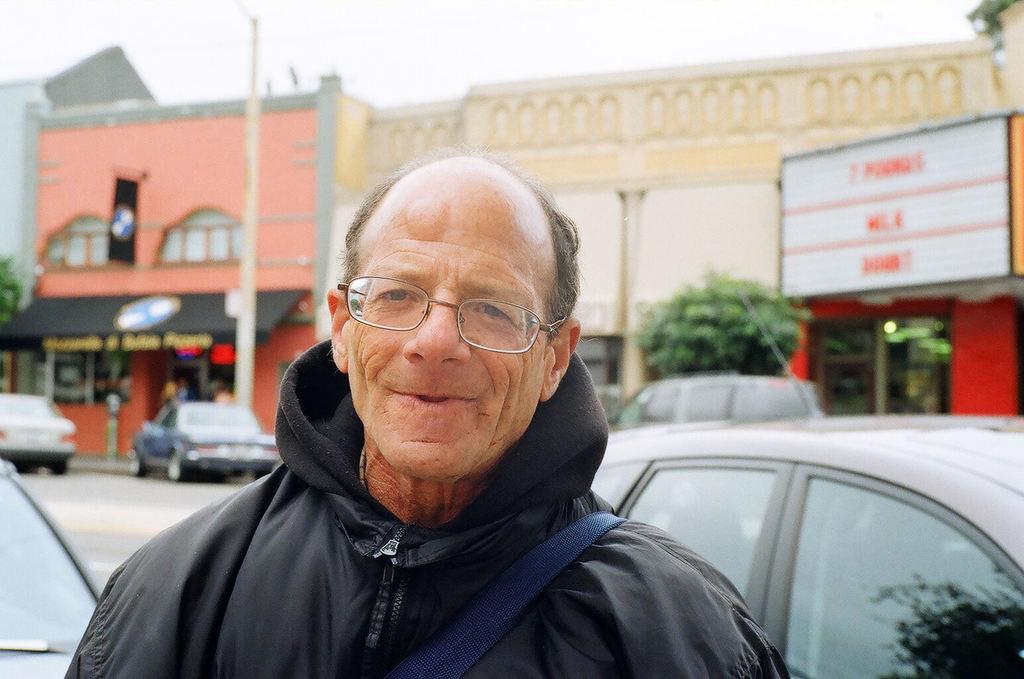Who is present in the image? There is a man in the image. What is the man's facial expression? The man is smiling. What accessory is the man wearing? The man is wearing spectacles. What can be seen behind the man? Cars are visible behind the man. What is visible in the background of the image? There are buildings and the sky in the background. What type of wood is used to make the cherry pie served for dinner in the image? There is no wood, cherry pie, or dinner present in the image. 